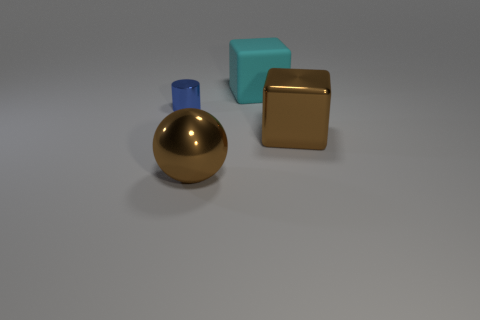Add 4 small yellow spheres. How many objects exist? 8 Subtract all cyan blocks. How many blocks are left? 1 Subtract all green balls. How many purple blocks are left? 0 Subtract all tiny cyan balls. Subtract all blue shiny objects. How many objects are left? 3 Add 1 cyan matte objects. How many cyan matte objects are left? 2 Add 3 blocks. How many blocks exist? 5 Subtract 0 green spheres. How many objects are left? 4 Subtract all cylinders. How many objects are left? 3 Subtract 1 cubes. How many cubes are left? 1 Subtract all green balls. Subtract all yellow cylinders. How many balls are left? 1 